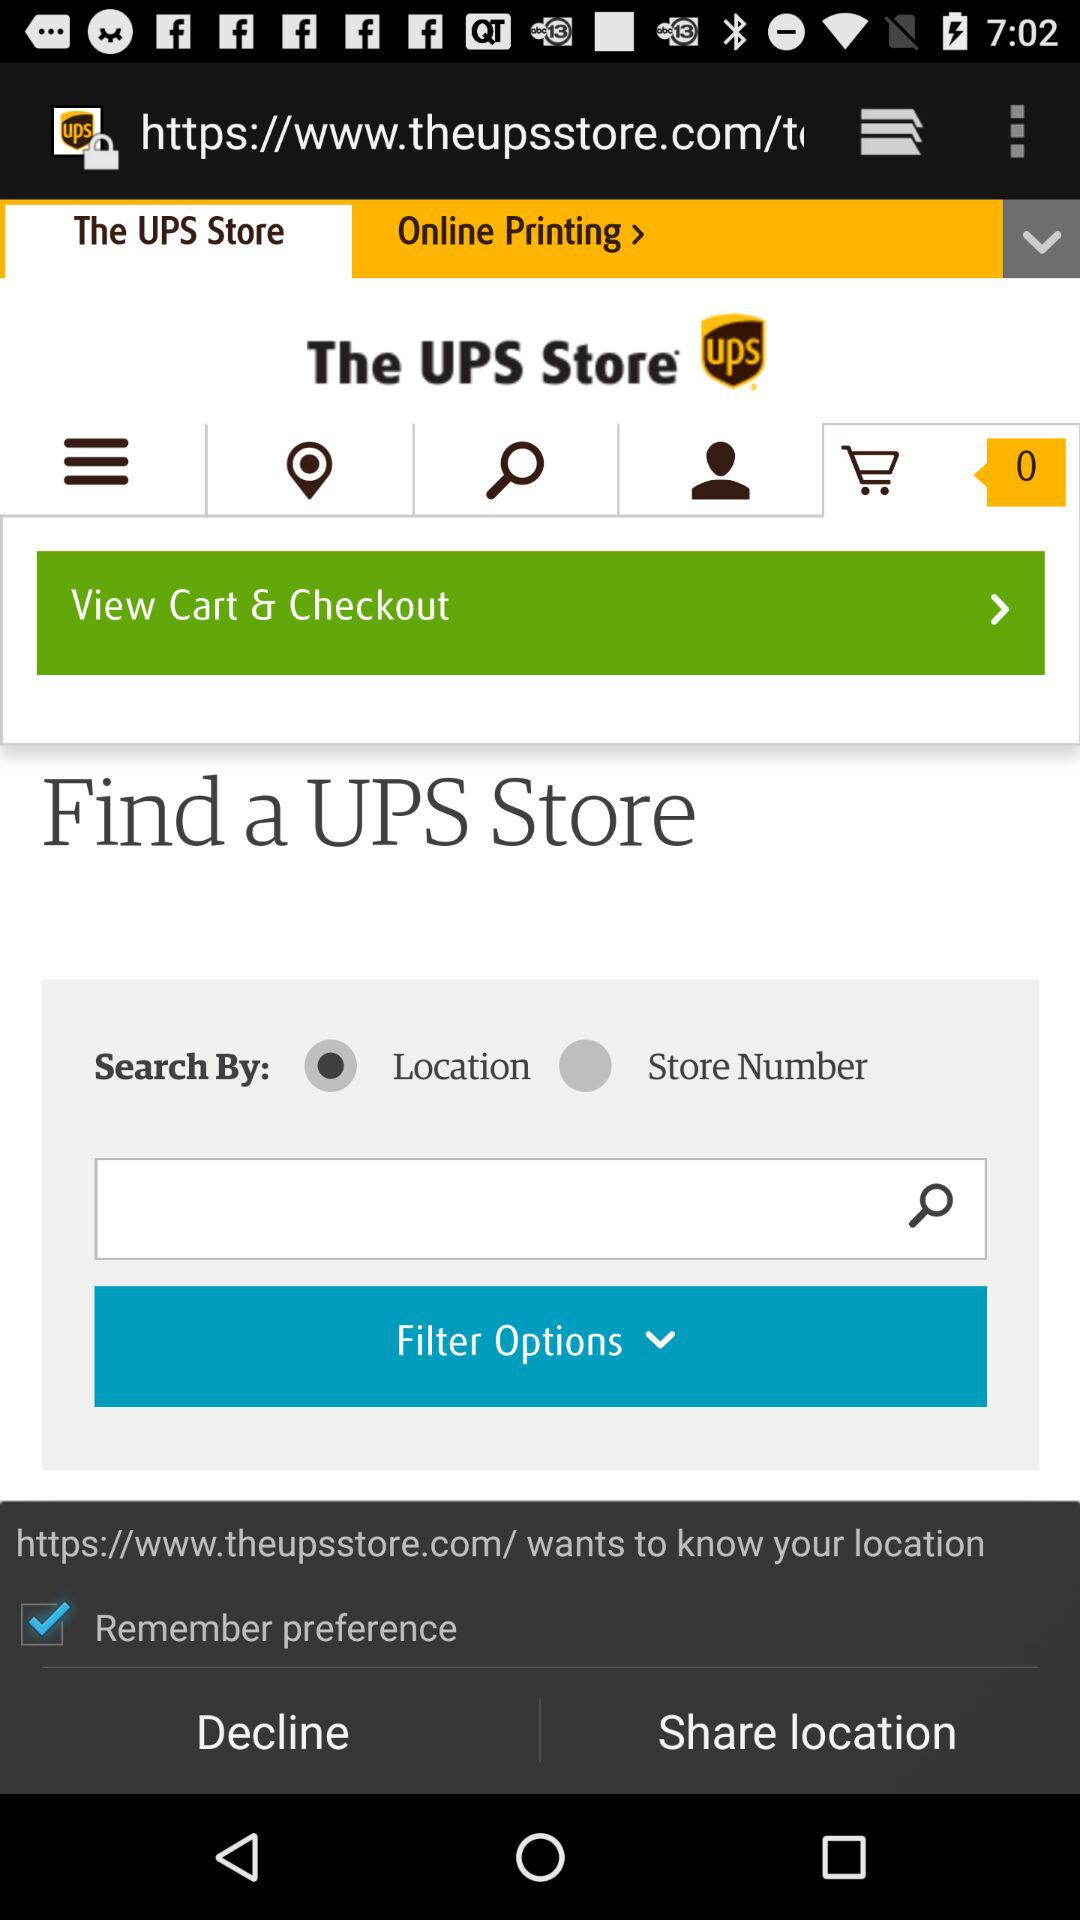Is "Store Number" selected or not selected? "Store Number" is not selected. 